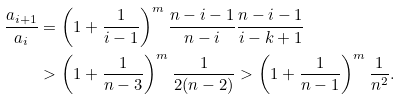<formula> <loc_0><loc_0><loc_500><loc_500>\frac { a _ { i + 1 } } { a _ { i } } & = \left ( 1 + \frac { 1 } { i - 1 } \right ) ^ { m } \frac { n - i - 1 } { n - i } \frac { n - i - 1 } { i - k + 1 } \\ & > \left ( 1 + \frac { 1 } { n - 3 } \right ) ^ { m } \frac { 1 } { 2 ( n - 2 ) } > \left ( 1 + \frac { 1 } { n - 1 } \right ) ^ { m } \frac { 1 } { n ^ { 2 } } .</formula> 